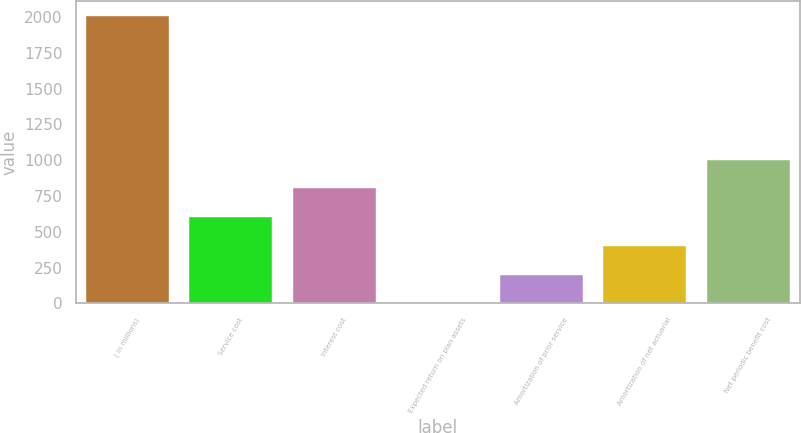Convert chart. <chart><loc_0><loc_0><loc_500><loc_500><bar_chart><fcel>( in millions)<fcel>Service cost<fcel>Interest cost<fcel>Expected return on plan assets<fcel>Amortization of prior service<fcel>Amortization of net actuarial<fcel>Net periodic benefit cost<nl><fcel>2009<fcel>603.54<fcel>804.32<fcel>1.2<fcel>201.98<fcel>402.76<fcel>1005.1<nl></chart> 